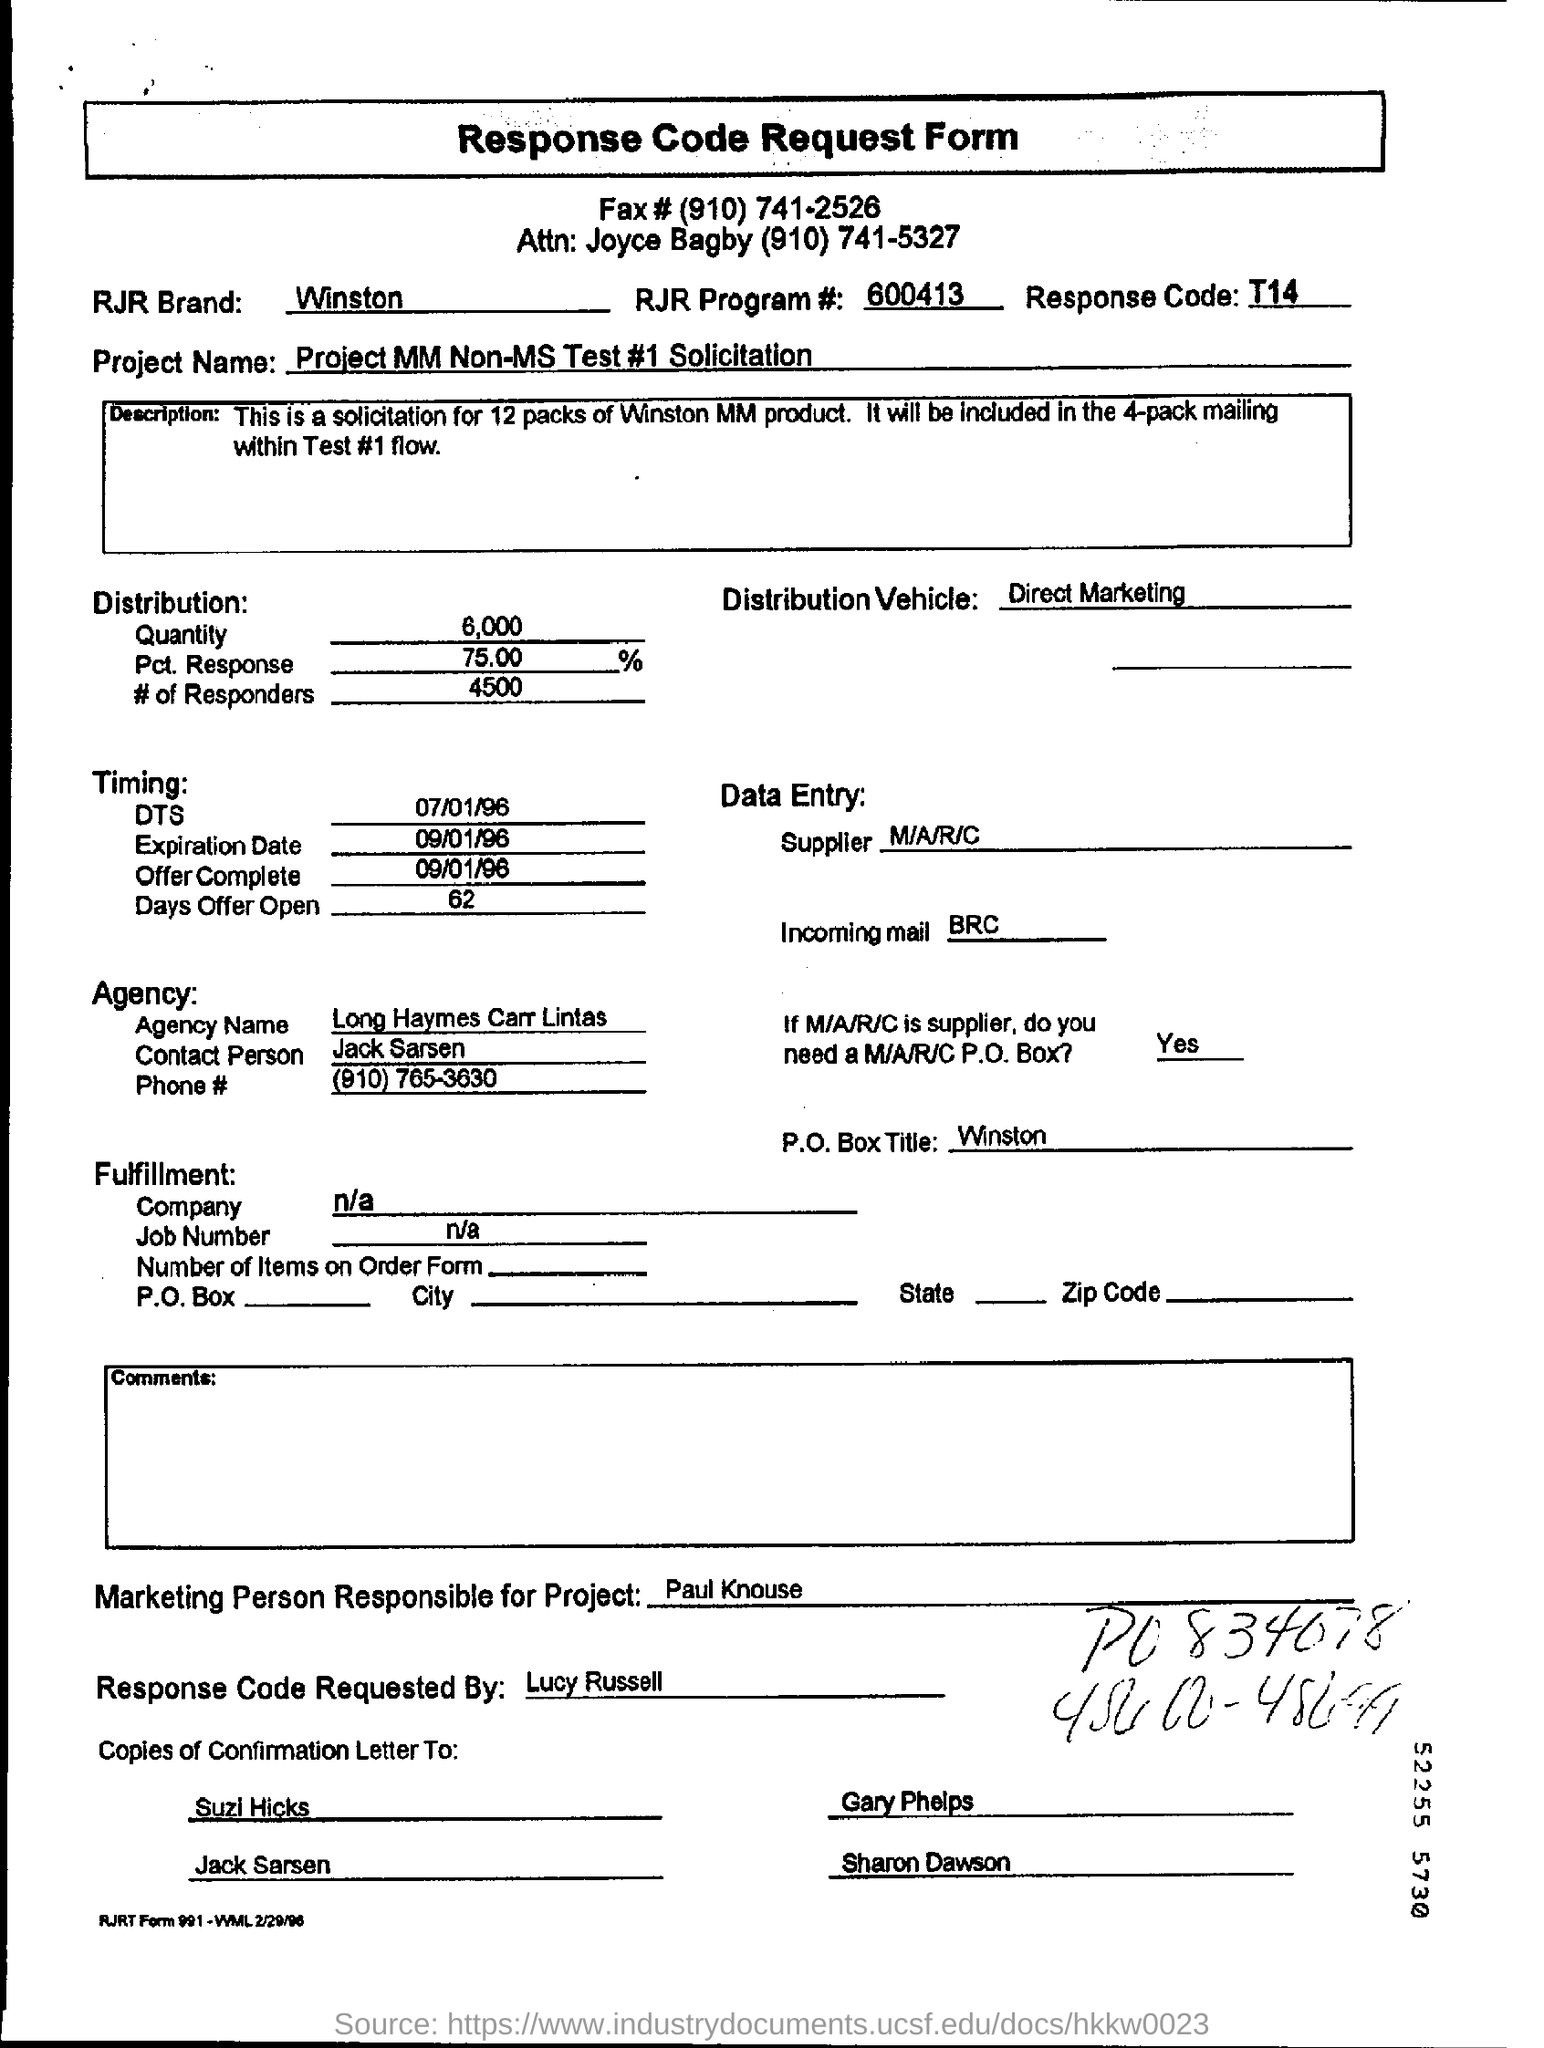Identify some key points in this picture. The response code is T14. The contact person from the agency is Jack Sarsen. The sentence is asking to provide the RJR program number that is mentioned on the response code request form, which is 600413. The request for the response code was made by Lucy Russell. The RJR brand mentioned on the response code request form is Winston. 